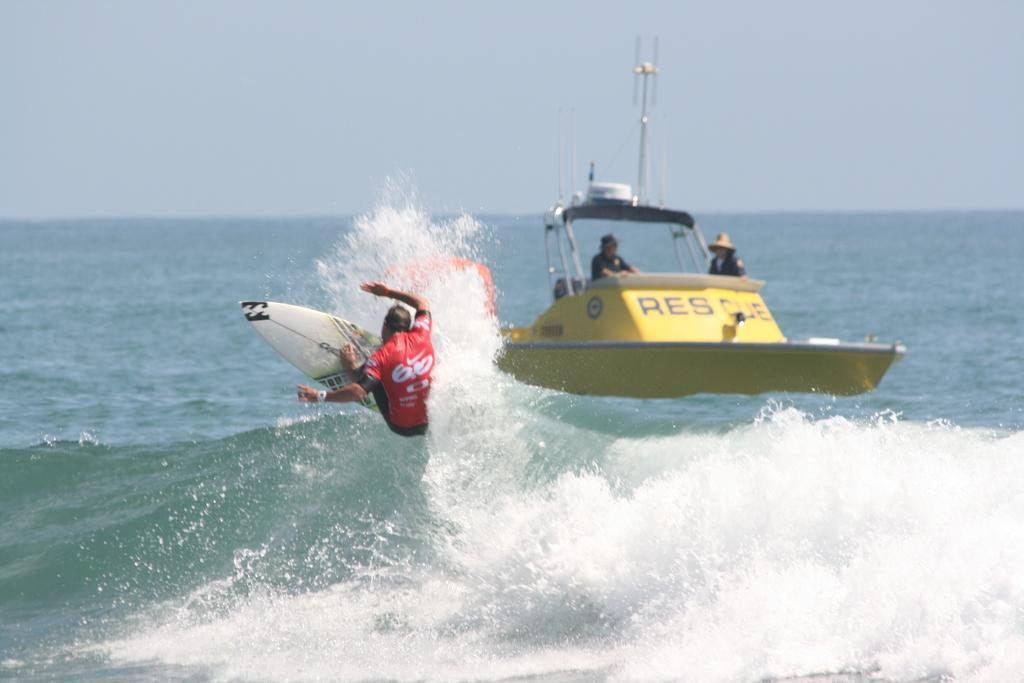<image>
Describe the image concisely. a boat on the water with thename like RESCA, but it's hard to read. 